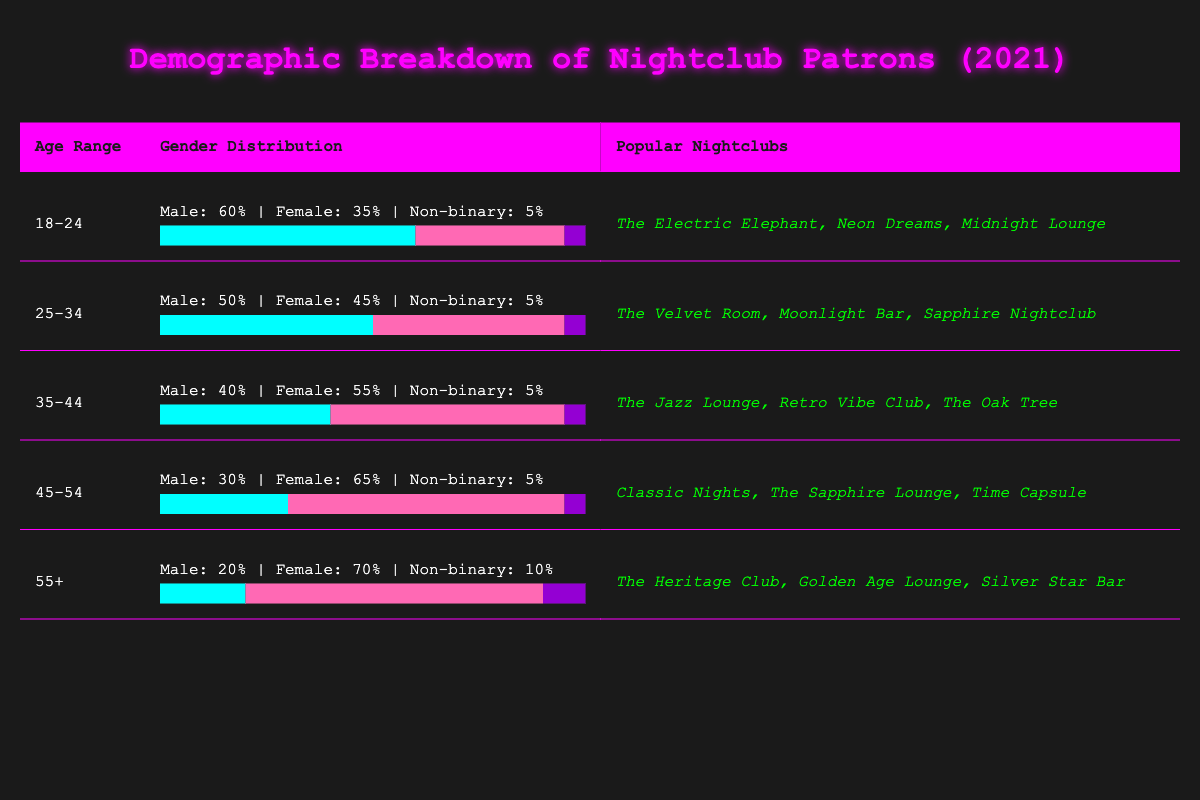What is the gender distribution for the age range 25-34? From the table, for the age range 25-34, the gender distribution is Male: 50%, Female: 45%, Non-binary: 5%.
Answer: Male: 50%, Female: 45%, Non-binary: 5% Which age range has the highest percentage of female patrons? By comparing the female percentages across all age ranges, the 55+ age range has the highest percentage at 70%.
Answer: 55+ What is the difference in male patron percentage between the 18-24 and 35-44 age ranges? The male patron percentage for 18-24 is 60% and for 35-44 is 40%. The difference is 60% - 40% = 20%.
Answer: 20% Are there more popular nightclubs for patrons aged 45-54 than for those aged 35-44? Both age ranges list three popular nightclubs, hence they have an equal number of popular nightclubs.
Answer: No What is the average percentage of non-binary patrons across all age ranges? Summing the non-binary percentages: 5 + 5 + 5 + 5 + 10 = 30. There are 5 data points, so the average is 30/5 = 6%.
Answer: 6% Which age range has the lowest male patron percentage? The age range 55+ has the lowest male patron percentage at 20%. Checking the values confirms this.
Answer: 55+ If we group patrons into two categories: under 35 and 35 or older, what is the percentage of male patrons in both groups? For under 35 (18-24 and 25-34), male patrons are (60% + 50%) / 2 = 55%. For 35 or older, male patrons are (40% + 30% + 20%) / 3 = 30%. Therefore, under 35 has a higher male percentage.
Answer: Under 35: 55%, 35 or older: 30% What percentage of patrons aged 45-54 identify as non-binary? The table indicates that the non-binary percentage for the age range 45-54 is 5%.
Answer: 5% Is it true that more than half of the patrons in the 35-44 age range are female? Yes, the female percentage for 35-44 is 55%, which is more than half.
Answer: Yes Which age group has the least representation in terms of male patrons at nightclubs? The 55+ age range has the least representation of male patrons at 20%. This is confirmed by the gender distribution data in the table.
Answer: 55+ 